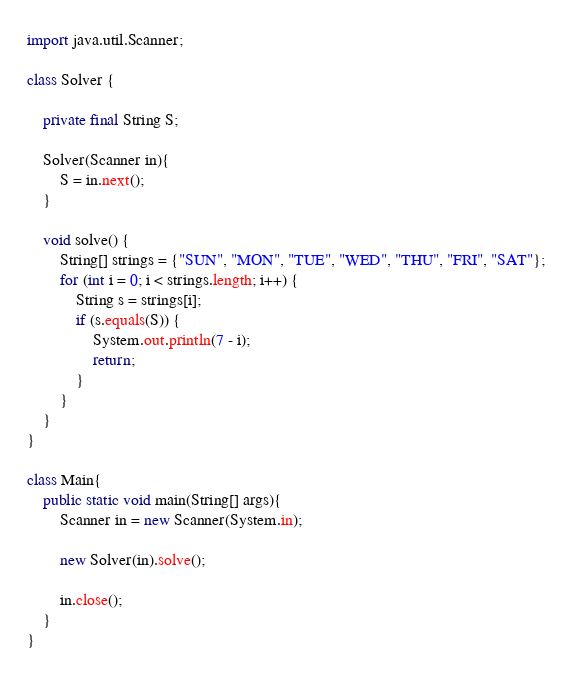Convert code to text. <code><loc_0><loc_0><loc_500><loc_500><_Java_>import java.util.Scanner;

class Solver {

    private final String S;

    Solver(Scanner in){
        S = in.next();
    }

    void solve() {
        String[] strings = {"SUN", "MON", "TUE", "WED", "THU", "FRI", "SAT"};
        for (int i = 0; i < strings.length; i++) {
            String s = strings[i];
            if (s.equals(S)) {
                System.out.println(7 - i);
                return;
            }
        }
    }
}

class Main{
    public static void main(String[] args){
        Scanner in = new Scanner(System.in);

        new Solver(in).solve();

        in.close();
    }
}</code> 